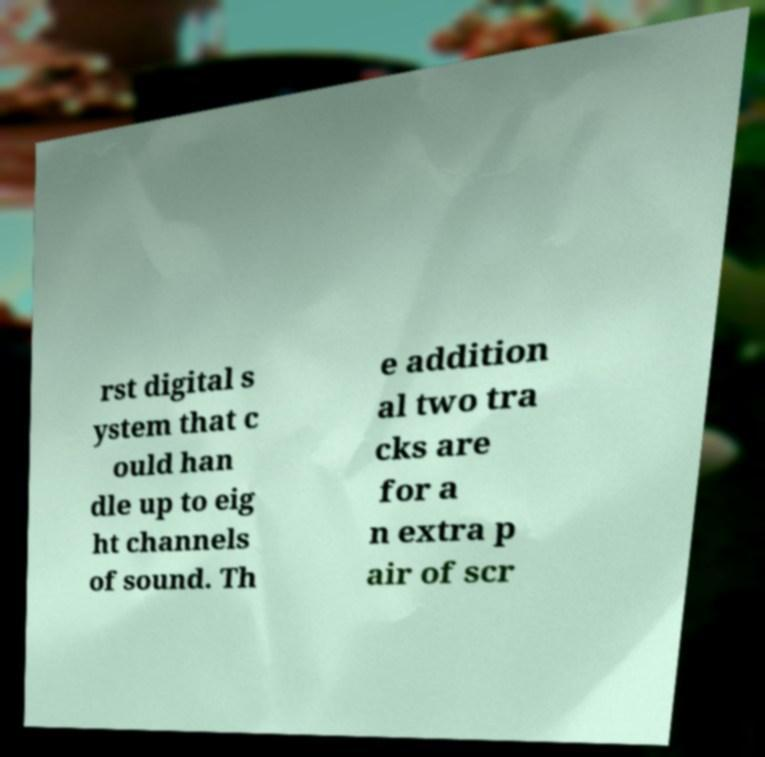For documentation purposes, I need the text within this image transcribed. Could you provide that? rst digital s ystem that c ould han dle up to eig ht channels of sound. Th e addition al two tra cks are for a n extra p air of scr 